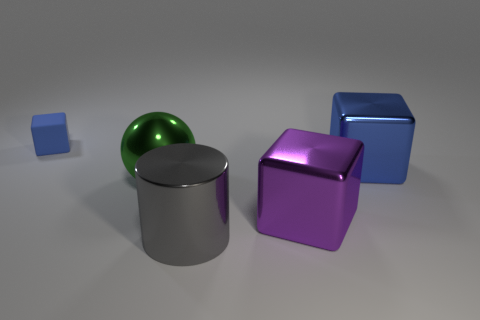Add 1 blue shiny cubes. How many objects exist? 6 Subtract all cylinders. How many objects are left? 4 Subtract all blue cubes. How many cubes are left? 1 Subtract all large blue cubes. How many cubes are left? 2 Subtract all gray cylinders. Subtract all small purple things. How many objects are left? 4 Add 2 metallic objects. How many metallic objects are left? 6 Add 2 large purple shiny objects. How many large purple shiny objects exist? 3 Subtract 1 green balls. How many objects are left? 4 Subtract 2 cubes. How many cubes are left? 1 Subtract all cyan cylinders. Subtract all red balls. How many cylinders are left? 1 